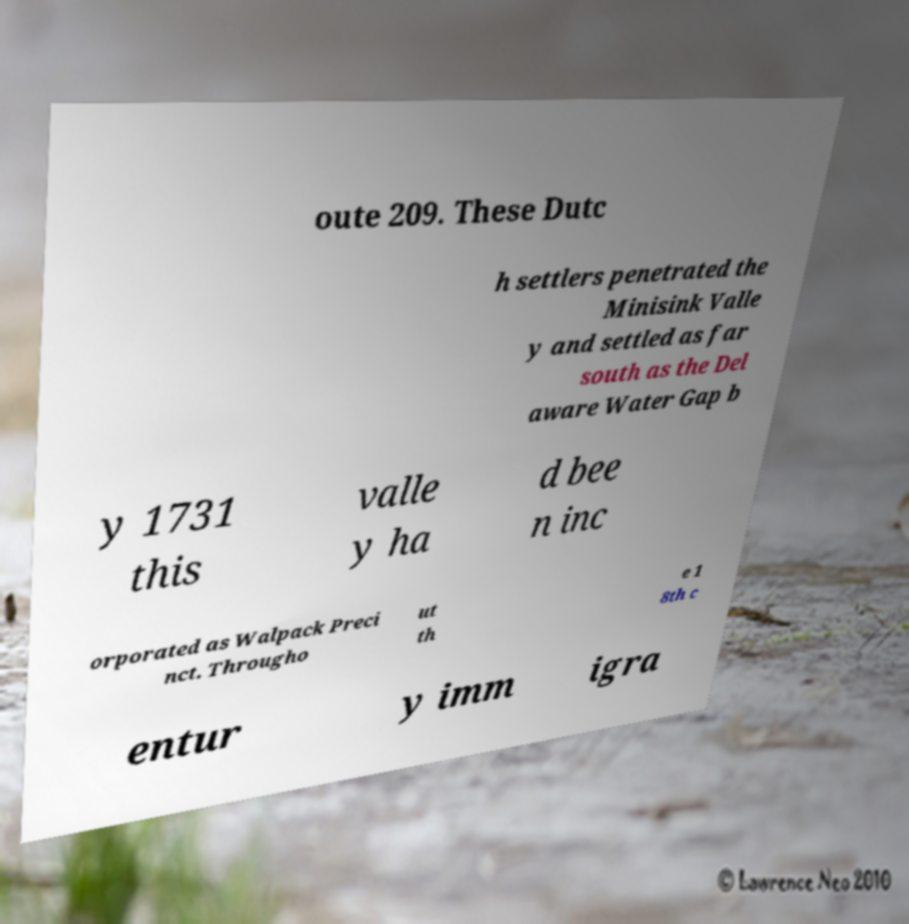There's text embedded in this image that I need extracted. Can you transcribe it verbatim? oute 209. These Dutc h settlers penetrated the Minisink Valle y and settled as far south as the Del aware Water Gap b y 1731 this valle y ha d bee n inc orporated as Walpack Preci nct. Througho ut th e 1 8th c entur y imm igra 